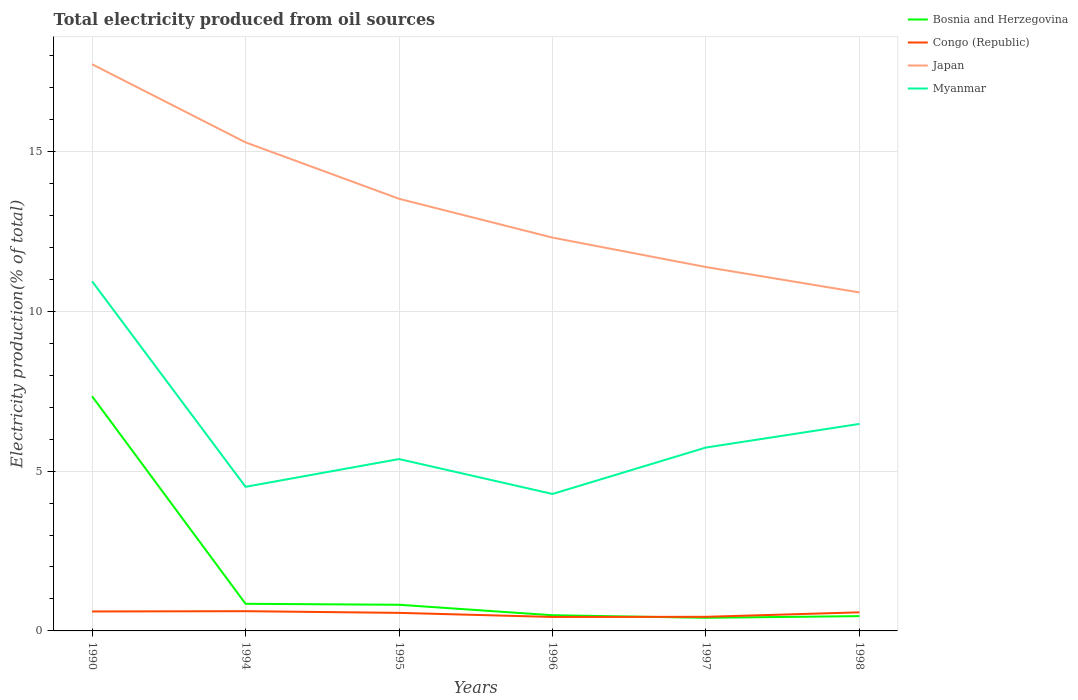Across all years, what is the maximum total electricity produced in Congo (Republic)?
Your answer should be very brief. 0.44. What is the total total electricity produced in Myanmar in the graph?
Give a very brief answer. -1.97. What is the difference between the highest and the second highest total electricity produced in Myanmar?
Provide a succinct answer. 6.65. What is the difference between the highest and the lowest total electricity produced in Congo (Republic)?
Your answer should be very brief. 4. How many lines are there?
Offer a terse response. 4. How many years are there in the graph?
Offer a very short reply. 6. Does the graph contain any zero values?
Your answer should be compact. No. Does the graph contain grids?
Your answer should be compact. Yes. Where does the legend appear in the graph?
Your response must be concise. Top right. How many legend labels are there?
Your answer should be very brief. 4. How are the legend labels stacked?
Make the answer very short. Vertical. What is the title of the graph?
Your answer should be very brief. Total electricity produced from oil sources. What is the label or title of the X-axis?
Your answer should be compact. Years. What is the Electricity production(% of total) of Bosnia and Herzegovina in 1990?
Provide a short and direct response. 7.34. What is the Electricity production(% of total) in Congo (Republic) in 1990?
Your response must be concise. 0.61. What is the Electricity production(% of total) of Japan in 1990?
Provide a succinct answer. 17.72. What is the Electricity production(% of total) of Myanmar in 1990?
Give a very brief answer. 10.94. What is the Electricity production(% of total) of Bosnia and Herzegovina in 1994?
Make the answer very short. 0.85. What is the Electricity production(% of total) in Congo (Republic) in 1994?
Ensure brevity in your answer.  0.62. What is the Electricity production(% of total) in Japan in 1994?
Your answer should be compact. 15.28. What is the Electricity production(% of total) of Myanmar in 1994?
Offer a terse response. 4.51. What is the Electricity production(% of total) of Bosnia and Herzegovina in 1995?
Offer a very short reply. 0.82. What is the Electricity production(% of total) of Congo (Republic) in 1995?
Make the answer very short. 0.56. What is the Electricity production(% of total) in Japan in 1995?
Your answer should be compact. 13.52. What is the Electricity production(% of total) of Myanmar in 1995?
Make the answer very short. 5.38. What is the Electricity production(% of total) of Bosnia and Herzegovina in 1996?
Your response must be concise. 0.49. What is the Electricity production(% of total) of Congo (Republic) in 1996?
Your answer should be very brief. 0.44. What is the Electricity production(% of total) in Japan in 1996?
Your answer should be compact. 12.3. What is the Electricity production(% of total) in Myanmar in 1996?
Your answer should be compact. 4.28. What is the Electricity production(% of total) in Bosnia and Herzegovina in 1997?
Provide a short and direct response. 0.41. What is the Electricity production(% of total) in Congo (Republic) in 1997?
Make the answer very short. 0.44. What is the Electricity production(% of total) in Japan in 1997?
Offer a terse response. 11.38. What is the Electricity production(% of total) of Myanmar in 1997?
Provide a succinct answer. 5.74. What is the Electricity production(% of total) in Bosnia and Herzegovina in 1998?
Provide a short and direct response. 0.46. What is the Electricity production(% of total) in Congo (Republic) in 1998?
Provide a short and direct response. 0.58. What is the Electricity production(% of total) in Japan in 1998?
Your response must be concise. 10.59. What is the Electricity production(% of total) of Myanmar in 1998?
Offer a very short reply. 6.47. Across all years, what is the maximum Electricity production(% of total) in Bosnia and Herzegovina?
Provide a succinct answer. 7.34. Across all years, what is the maximum Electricity production(% of total) of Congo (Republic)?
Your answer should be compact. 0.62. Across all years, what is the maximum Electricity production(% of total) of Japan?
Provide a succinct answer. 17.72. Across all years, what is the maximum Electricity production(% of total) of Myanmar?
Give a very brief answer. 10.94. Across all years, what is the minimum Electricity production(% of total) of Bosnia and Herzegovina?
Ensure brevity in your answer.  0.41. Across all years, what is the minimum Electricity production(% of total) in Congo (Republic)?
Offer a very short reply. 0.44. Across all years, what is the minimum Electricity production(% of total) of Japan?
Your answer should be very brief. 10.59. Across all years, what is the minimum Electricity production(% of total) in Myanmar?
Keep it short and to the point. 4.28. What is the total Electricity production(% of total) in Bosnia and Herzegovina in the graph?
Offer a very short reply. 10.37. What is the total Electricity production(% of total) of Congo (Republic) in the graph?
Make the answer very short. 3.25. What is the total Electricity production(% of total) in Japan in the graph?
Provide a succinct answer. 80.8. What is the total Electricity production(% of total) of Myanmar in the graph?
Your response must be concise. 37.32. What is the difference between the Electricity production(% of total) of Bosnia and Herzegovina in 1990 and that in 1994?
Your answer should be very brief. 6.49. What is the difference between the Electricity production(% of total) in Congo (Republic) in 1990 and that in 1994?
Ensure brevity in your answer.  -0.01. What is the difference between the Electricity production(% of total) of Japan in 1990 and that in 1994?
Provide a short and direct response. 2.44. What is the difference between the Electricity production(% of total) in Myanmar in 1990 and that in 1994?
Provide a short and direct response. 6.43. What is the difference between the Electricity production(% of total) in Bosnia and Herzegovina in 1990 and that in 1995?
Provide a short and direct response. 6.52. What is the difference between the Electricity production(% of total) in Congo (Republic) in 1990 and that in 1995?
Offer a terse response. 0.04. What is the difference between the Electricity production(% of total) of Japan in 1990 and that in 1995?
Provide a short and direct response. 4.21. What is the difference between the Electricity production(% of total) in Myanmar in 1990 and that in 1995?
Make the answer very short. 5.56. What is the difference between the Electricity production(% of total) of Bosnia and Herzegovina in 1990 and that in 1996?
Keep it short and to the point. 6.85. What is the difference between the Electricity production(% of total) of Congo (Republic) in 1990 and that in 1996?
Provide a succinct answer. 0.17. What is the difference between the Electricity production(% of total) in Japan in 1990 and that in 1996?
Your response must be concise. 5.42. What is the difference between the Electricity production(% of total) in Myanmar in 1990 and that in 1996?
Provide a short and direct response. 6.65. What is the difference between the Electricity production(% of total) in Bosnia and Herzegovina in 1990 and that in 1997?
Provide a succinct answer. 6.93. What is the difference between the Electricity production(% of total) in Congo (Republic) in 1990 and that in 1997?
Provide a short and direct response. 0.17. What is the difference between the Electricity production(% of total) in Japan in 1990 and that in 1997?
Your answer should be very brief. 6.34. What is the difference between the Electricity production(% of total) in Myanmar in 1990 and that in 1997?
Your answer should be very brief. 5.2. What is the difference between the Electricity production(% of total) in Bosnia and Herzegovina in 1990 and that in 1998?
Your response must be concise. 6.88. What is the difference between the Electricity production(% of total) of Congo (Republic) in 1990 and that in 1998?
Offer a very short reply. 0.03. What is the difference between the Electricity production(% of total) of Japan in 1990 and that in 1998?
Give a very brief answer. 7.14. What is the difference between the Electricity production(% of total) of Myanmar in 1990 and that in 1998?
Keep it short and to the point. 4.46. What is the difference between the Electricity production(% of total) in Bosnia and Herzegovina in 1994 and that in 1995?
Make the answer very short. 0.03. What is the difference between the Electricity production(% of total) in Congo (Republic) in 1994 and that in 1995?
Your answer should be compact. 0.05. What is the difference between the Electricity production(% of total) of Japan in 1994 and that in 1995?
Provide a short and direct response. 1.76. What is the difference between the Electricity production(% of total) of Myanmar in 1994 and that in 1995?
Provide a short and direct response. -0.87. What is the difference between the Electricity production(% of total) in Bosnia and Herzegovina in 1994 and that in 1996?
Make the answer very short. 0.36. What is the difference between the Electricity production(% of total) in Congo (Republic) in 1994 and that in 1996?
Offer a terse response. 0.18. What is the difference between the Electricity production(% of total) of Japan in 1994 and that in 1996?
Offer a very short reply. 2.98. What is the difference between the Electricity production(% of total) in Myanmar in 1994 and that in 1996?
Ensure brevity in your answer.  0.22. What is the difference between the Electricity production(% of total) of Bosnia and Herzegovina in 1994 and that in 1997?
Give a very brief answer. 0.44. What is the difference between the Electricity production(% of total) of Congo (Republic) in 1994 and that in 1997?
Your answer should be compact. 0.18. What is the difference between the Electricity production(% of total) in Japan in 1994 and that in 1997?
Ensure brevity in your answer.  3.9. What is the difference between the Electricity production(% of total) in Myanmar in 1994 and that in 1997?
Keep it short and to the point. -1.23. What is the difference between the Electricity production(% of total) in Bosnia and Herzegovina in 1994 and that in 1998?
Keep it short and to the point. 0.39. What is the difference between the Electricity production(% of total) of Congo (Republic) in 1994 and that in 1998?
Offer a terse response. 0.04. What is the difference between the Electricity production(% of total) in Japan in 1994 and that in 1998?
Make the answer very short. 4.69. What is the difference between the Electricity production(% of total) of Myanmar in 1994 and that in 1998?
Your response must be concise. -1.97. What is the difference between the Electricity production(% of total) of Bosnia and Herzegovina in 1995 and that in 1996?
Offer a very short reply. 0.33. What is the difference between the Electricity production(% of total) of Congo (Republic) in 1995 and that in 1996?
Give a very brief answer. 0.13. What is the difference between the Electricity production(% of total) in Japan in 1995 and that in 1996?
Make the answer very short. 1.21. What is the difference between the Electricity production(% of total) of Myanmar in 1995 and that in 1996?
Provide a succinct answer. 1.09. What is the difference between the Electricity production(% of total) in Bosnia and Herzegovina in 1995 and that in 1997?
Your answer should be very brief. 0.41. What is the difference between the Electricity production(% of total) of Congo (Republic) in 1995 and that in 1997?
Your answer should be compact. 0.12. What is the difference between the Electricity production(% of total) of Japan in 1995 and that in 1997?
Make the answer very short. 2.14. What is the difference between the Electricity production(% of total) of Myanmar in 1995 and that in 1997?
Ensure brevity in your answer.  -0.36. What is the difference between the Electricity production(% of total) in Bosnia and Herzegovina in 1995 and that in 1998?
Your answer should be compact. 0.36. What is the difference between the Electricity production(% of total) of Congo (Republic) in 1995 and that in 1998?
Keep it short and to the point. -0.02. What is the difference between the Electricity production(% of total) of Japan in 1995 and that in 1998?
Provide a short and direct response. 2.93. What is the difference between the Electricity production(% of total) in Myanmar in 1995 and that in 1998?
Your answer should be very brief. -1.1. What is the difference between the Electricity production(% of total) of Bosnia and Herzegovina in 1996 and that in 1997?
Provide a succinct answer. 0.08. What is the difference between the Electricity production(% of total) of Congo (Republic) in 1996 and that in 1997?
Keep it short and to the point. -0. What is the difference between the Electricity production(% of total) of Japan in 1996 and that in 1997?
Keep it short and to the point. 0.92. What is the difference between the Electricity production(% of total) of Myanmar in 1996 and that in 1997?
Offer a terse response. -1.45. What is the difference between the Electricity production(% of total) of Bosnia and Herzegovina in 1996 and that in 1998?
Your answer should be very brief. 0.03. What is the difference between the Electricity production(% of total) in Congo (Republic) in 1996 and that in 1998?
Your answer should be compact. -0.14. What is the difference between the Electricity production(% of total) in Japan in 1996 and that in 1998?
Ensure brevity in your answer.  1.72. What is the difference between the Electricity production(% of total) in Myanmar in 1996 and that in 1998?
Your answer should be very brief. -2.19. What is the difference between the Electricity production(% of total) in Bosnia and Herzegovina in 1997 and that in 1998?
Provide a short and direct response. -0.05. What is the difference between the Electricity production(% of total) in Congo (Republic) in 1997 and that in 1998?
Your answer should be compact. -0.14. What is the difference between the Electricity production(% of total) of Japan in 1997 and that in 1998?
Ensure brevity in your answer.  0.79. What is the difference between the Electricity production(% of total) of Myanmar in 1997 and that in 1998?
Offer a very short reply. -0.74. What is the difference between the Electricity production(% of total) of Bosnia and Herzegovina in 1990 and the Electricity production(% of total) of Congo (Republic) in 1994?
Offer a very short reply. 6.72. What is the difference between the Electricity production(% of total) of Bosnia and Herzegovina in 1990 and the Electricity production(% of total) of Japan in 1994?
Give a very brief answer. -7.94. What is the difference between the Electricity production(% of total) of Bosnia and Herzegovina in 1990 and the Electricity production(% of total) of Myanmar in 1994?
Provide a succinct answer. 2.83. What is the difference between the Electricity production(% of total) in Congo (Republic) in 1990 and the Electricity production(% of total) in Japan in 1994?
Your answer should be very brief. -14.67. What is the difference between the Electricity production(% of total) in Congo (Republic) in 1990 and the Electricity production(% of total) in Myanmar in 1994?
Offer a terse response. -3.9. What is the difference between the Electricity production(% of total) of Japan in 1990 and the Electricity production(% of total) of Myanmar in 1994?
Provide a succinct answer. 13.22. What is the difference between the Electricity production(% of total) in Bosnia and Herzegovina in 1990 and the Electricity production(% of total) in Congo (Republic) in 1995?
Make the answer very short. 6.78. What is the difference between the Electricity production(% of total) in Bosnia and Herzegovina in 1990 and the Electricity production(% of total) in Japan in 1995?
Offer a very short reply. -6.18. What is the difference between the Electricity production(% of total) of Bosnia and Herzegovina in 1990 and the Electricity production(% of total) of Myanmar in 1995?
Give a very brief answer. 1.96. What is the difference between the Electricity production(% of total) of Congo (Republic) in 1990 and the Electricity production(% of total) of Japan in 1995?
Your answer should be compact. -12.91. What is the difference between the Electricity production(% of total) of Congo (Republic) in 1990 and the Electricity production(% of total) of Myanmar in 1995?
Make the answer very short. -4.77. What is the difference between the Electricity production(% of total) of Japan in 1990 and the Electricity production(% of total) of Myanmar in 1995?
Your response must be concise. 12.35. What is the difference between the Electricity production(% of total) of Bosnia and Herzegovina in 1990 and the Electricity production(% of total) of Congo (Republic) in 1996?
Offer a terse response. 6.9. What is the difference between the Electricity production(% of total) of Bosnia and Herzegovina in 1990 and the Electricity production(% of total) of Japan in 1996?
Make the answer very short. -4.96. What is the difference between the Electricity production(% of total) of Bosnia and Herzegovina in 1990 and the Electricity production(% of total) of Myanmar in 1996?
Your response must be concise. 3.06. What is the difference between the Electricity production(% of total) in Congo (Republic) in 1990 and the Electricity production(% of total) in Japan in 1996?
Offer a very short reply. -11.69. What is the difference between the Electricity production(% of total) in Congo (Republic) in 1990 and the Electricity production(% of total) in Myanmar in 1996?
Your response must be concise. -3.68. What is the difference between the Electricity production(% of total) of Japan in 1990 and the Electricity production(% of total) of Myanmar in 1996?
Provide a succinct answer. 13.44. What is the difference between the Electricity production(% of total) of Bosnia and Herzegovina in 1990 and the Electricity production(% of total) of Congo (Republic) in 1997?
Provide a succinct answer. 6.9. What is the difference between the Electricity production(% of total) in Bosnia and Herzegovina in 1990 and the Electricity production(% of total) in Japan in 1997?
Provide a succinct answer. -4.04. What is the difference between the Electricity production(% of total) in Bosnia and Herzegovina in 1990 and the Electricity production(% of total) in Myanmar in 1997?
Your answer should be compact. 1.6. What is the difference between the Electricity production(% of total) in Congo (Republic) in 1990 and the Electricity production(% of total) in Japan in 1997?
Your response must be concise. -10.77. What is the difference between the Electricity production(% of total) in Congo (Republic) in 1990 and the Electricity production(% of total) in Myanmar in 1997?
Provide a succinct answer. -5.13. What is the difference between the Electricity production(% of total) of Japan in 1990 and the Electricity production(% of total) of Myanmar in 1997?
Your answer should be very brief. 11.99. What is the difference between the Electricity production(% of total) of Bosnia and Herzegovina in 1990 and the Electricity production(% of total) of Congo (Republic) in 1998?
Make the answer very short. 6.76. What is the difference between the Electricity production(% of total) in Bosnia and Herzegovina in 1990 and the Electricity production(% of total) in Japan in 1998?
Offer a very short reply. -3.25. What is the difference between the Electricity production(% of total) of Bosnia and Herzegovina in 1990 and the Electricity production(% of total) of Myanmar in 1998?
Ensure brevity in your answer.  0.87. What is the difference between the Electricity production(% of total) in Congo (Republic) in 1990 and the Electricity production(% of total) in Japan in 1998?
Your answer should be compact. -9.98. What is the difference between the Electricity production(% of total) in Congo (Republic) in 1990 and the Electricity production(% of total) in Myanmar in 1998?
Your answer should be compact. -5.87. What is the difference between the Electricity production(% of total) of Japan in 1990 and the Electricity production(% of total) of Myanmar in 1998?
Provide a succinct answer. 11.25. What is the difference between the Electricity production(% of total) of Bosnia and Herzegovina in 1994 and the Electricity production(% of total) of Congo (Republic) in 1995?
Your answer should be compact. 0.28. What is the difference between the Electricity production(% of total) in Bosnia and Herzegovina in 1994 and the Electricity production(% of total) in Japan in 1995?
Offer a terse response. -12.67. What is the difference between the Electricity production(% of total) of Bosnia and Herzegovina in 1994 and the Electricity production(% of total) of Myanmar in 1995?
Offer a very short reply. -4.53. What is the difference between the Electricity production(% of total) in Congo (Republic) in 1994 and the Electricity production(% of total) in Japan in 1995?
Your answer should be compact. -12.9. What is the difference between the Electricity production(% of total) in Congo (Republic) in 1994 and the Electricity production(% of total) in Myanmar in 1995?
Offer a very short reply. -4.76. What is the difference between the Electricity production(% of total) in Japan in 1994 and the Electricity production(% of total) in Myanmar in 1995?
Offer a very short reply. 9.91. What is the difference between the Electricity production(% of total) of Bosnia and Herzegovina in 1994 and the Electricity production(% of total) of Congo (Republic) in 1996?
Offer a very short reply. 0.41. What is the difference between the Electricity production(% of total) of Bosnia and Herzegovina in 1994 and the Electricity production(% of total) of Japan in 1996?
Keep it short and to the point. -11.45. What is the difference between the Electricity production(% of total) in Bosnia and Herzegovina in 1994 and the Electricity production(% of total) in Myanmar in 1996?
Your response must be concise. -3.44. What is the difference between the Electricity production(% of total) of Congo (Republic) in 1994 and the Electricity production(% of total) of Japan in 1996?
Your answer should be very brief. -11.69. What is the difference between the Electricity production(% of total) in Congo (Republic) in 1994 and the Electricity production(% of total) in Myanmar in 1996?
Your answer should be compact. -3.67. What is the difference between the Electricity production(% of total) of Japan in 1994 and the Electricity production(% of total) of Myanmar in 1996?
Make the answer very short. 11. What is the difference between the Electricity production(% of total) in Bosnia and Herzegovina in 1994 and the Electricity production(% of total) in Congo (Republic) in 1997?
Give a very brief answer. 0.41. What is the difference between the Electricity production(% of total) in Bosnia and Herzegovina in 1994 and the Electricity production(% of total) in Japan in 1997?
Ensure brevity in your answer.  -10.53. What is the difference between the Electricity production(% of total) of Bosnia and Herzegovina in 1994 and the Electricity production(% of total) of Myanmar in 1997?
Make the answer very short. -4.89. What is the difference between the Electricity production(% of total) in Congo (Republic) in 1994 and the Electricity production(% of total) in Japan in 1997?
Make the answer very short. -10.76. What is the difference between the Electricity production(% of total) of Congo (Republic) in 1994 and the Electricity production(% of total) of Myanmar in 1997?
Provide a short and direct response. -5.12. What is the difference between the Electricity production(% of total) in Japan in 1994 and the Electricity production(% of total) in Myanmar in 1997?
Your answer should be compact. 9.54. What is the difference between the Electricity production(% of total) of Bosnia and Herzegovina in 1994 and the Electricity production(% of total) of Congo (Republic) in 1998?
Keep it short and to the point. 0.27. What is the difference between the Electricity production(% of total) of Bosnia and Herzegovina in 1994 and the Electricity production(% of total) of Japan in 1998?
Make the answer very short. -9.74. What is the difference between the Electricity production(% of total) in Bosnia and Herzegovina in 1994 and the Electricity production(% of total) in Myanmar in 1998?
Keep it short and to the point. -5.63. What is the difference between the Electricity production(% of total) in Congo (Republic) in 1994 and the Electricity production(% of total) in Japan in 1998?
Offer a terse response. -9.97. What is the difference between the Electricity production(% of total) of Congo (Republic) in 1994 and the Electricity production(% of total) of Myanmar in 1998?
Offer a terse response. -5.86. What is the difference between the Electricity production(% of total) in Japan in 1994 and the Electricity production(% of total) in Myanmar in 1998?
Ensure brevity in your answer.  8.81. What is the difference between the Electricity production(% of total) in Bosnia and Herzegovina in 1995 and the Electricity production(% of total) in Congo (Republic) in 1996?
Give a very brief answer. 0.38. What is the difference between the Electricity production(% of total) in Bosnia and Herzegovina in 1995 and the Electricity production(% of total) in Japan in 1996?
Provide a succinct answer. -11.48. What is the difference between the Electricity production(% of total) of Bosnia and Herzegovina in 1995 and the Electricity production(% of total) of Myanmar in 1996?
Offer a very short reply. -3.47. What is the difference between the Electricity production(% of total) in Congo (Republic) in 1995 and the Electricity production(% of total) in Japan in 1996?
Your response must be concise. -11.74. What is the difference between the Electricity production(% of total) in Congo (Republic) in 1995 and the Electricity production(% of total) in Myanmar in 1996?
Make the answer very short. -3.72. What is the difference between the Electricity production(% of total) of Japan in 1995 and the Electricity production(% of total) of Myanmar in 1996?
Your answer should be very brief. 9.23. What is the difference between the Electricity production(% of total) in Bosnia and Herzegovina in 1995 and the Electricity production(% of total) in Congo (Republic) in 1997?
Your answer should be compact. 0.38. What is the difference between the Electricity production(% of total) in Bosnia and Herzegovina in 1995 and the Electricity production(% of total) in Japan in 1997?
Your answer should be very brief. -10.56. What is the difference between the Electricity production(% of total) in Bosnia and Herzegovina in 1995 and the Electricity production(% of total) in Myanmar in 1997?
Ensure brevity in your answer.  -4.92. What is the difference between the Electricity production(% of total) of Congo (Republic) in 1995 and the Electricity production(% of total) of Japan in 1997?
Give a very brief answer. -10.82. What is the difference between the Electricity production(% of total) in Congo (Republic) in 1995 and the Electricity production(% of total) in Myanmar in 1997?
Ensure brevity in your answer.  -5.17. What is the difference between the Electricity production(% of total) in Japan in 1995 and the Electricity production(% of total) in Myanmar in 1997?
Provide a succinct answer. 7.78. What is the difference between the Electricity production(% of total) in Bosnia and Herzegovina in 1995 and the Electricity production(% of total) in Congo (Republic) in 1998?
Ensure brevity in your answer.  0.24. What is the difference between the Electricity production(% of total) of Bosnia and Herzegovina in 1995 and the Electricity production(% of total) of Japan in 1998?
Your response must be concise. -9.77. What is the difference between the Electricity production(% of total) of Bosnia and Herzegovina in 1995 and the Electricity production(% of total) of Myanmar in 1998?
Provide a succinct answer. -5.66. What is the difference between the Electricity production(% of total) of Congo (Republic) in 1995 and the Electricity production(% of total) of Japan in 1998?
Provide a short and direct response. -10.02. What is the difference between the Electricity production(% of total) in Congo (Republic) in 1995 and the Electricity production(% of total) in Myanmar in 1998?
Your answer should be compact. -5.91. What is the difference between the Electricity production(% of total) in Japan in 1995 and the Electricity production(% of total) in Myanmar in 1998?
Give a very brief answer. 7.04. What is the difference between the Electricity production(% of total) in Bosnia and Herzegovina in 1996 and the Electricity production(% of total) in Congo (Republic) in 1997?
Give a very brief answer. 0.05. What is the difference between the Electricity production(% of total) of Bosnia and Herzegovina in 1996 and the Electricity production(% of total) of Japan in 1997?
Your answer should be very brief. -10.89. What is the difference between the Electricity production(% of total) of Bosnia and Herzegovina in 1996 and the Electricity production(% of total) of Myanmar in 1997?
Keep it short and to the point. -5.25. What is the difference between the Electricity production(% of total) in Congo (Republic) in 1996 and the Electricity production(% of total) in Japan in 1997?
Make the answer very short. -10.95. What is the difference between the Electricity production(% of total) in Congo (Republic) in 1996 and the Electricity production(% of total) in Myanmar in 1997?
Provide a short and direct response. -5.3. What is the difference between the Electricity production(% of total) in Japan in 1996 and the Electricity production(% of total) in Myanmar in 1997?
Keep it short and to the point. 6.57. What is the difference between the Electricity production(% of total) in Bosnia and Herzegovina in 1996 and the Electricity production(% of total) in Congo (Republic) in 1998?
Provide a succinct answer. -0.09. What is the difference between the Electricity production(% of total) of Bosnia and Herzegovina in 1996 and the Electricity production(% of total) of Japan in 1998?
Make the answer very short. -10.1. What is the difference between the Electricity production(% of total) of Bosnia and Herzegovina in 1996 and the Electricity production(% of total) of Myanmar in 1998?
Provide a succinct answer. -5.98. What is the difference between the Electricity production(% of total) in Congo (Republic) in 1996 and the Electricity production(% of total) in Japan in 1998?
Keep it short and to the point. -10.15. What is the difference between the Electricity production(% of total) of Congo (Republic) in 1996 and the Electricity production(% of total) of Myanmar in 1998?
Keep it short and to the point. -6.04. What is the difference between the Electricity production(% of total) in Japan in 1996 and the Electricity production(% of total) in Myanmar in 1998?
Make the answer very short. 5.83. What is the difference between the Electricity production(% of total) in Bosnia and Herzegovina in 1997 and the Electricity production(% of total) in Congo (Republic) in 1998?
Keep it short and to the point. -0.17. What is the difference between the Electricity production(% of total) of Bosnia and Herzegovina in 1997 and the Electricity production(% of total) of Japan in 1998?
Offer a terse response. -10.18. What is the difference between the Electricity production(% of total) in Bosnia and Herzegovina in 1997 and the Electricity production(% of total) in Myanmar in 1998?
Offer a terse response. -6.06. What is the difference between the Electricity production(% of total) in Congo (Republic) in 1997 and the Electricity production(% of total) in Japan in 1998?
Provide a succinct answer. -10.15. What is the difference between the Electricity production(% of total) of Congo (Republic) in 1997 and the Electricity production(% of total) of Myanmar in 1998?
Keep it short and to the point. -6.03. What is the difference between the Electricity production(% of total) of Japan in 1997 and the Electricity production(% of total) of Myanmar in 1998?
Offer a terse response. 4.91. What is the average Electricity production(% of total) in Bosnia and Herzegovina per year?
Provide a succinct answer. 1.73. What is the average Electricity production(% of total) in Congo (Republic) per year?
Make the answer very short. 0.54. What is the average Electricity production(% of total) of Japan per year?
Your response must be concise. 13.47. What is the average Electricity production(% of total) of Myanmar per year?
Your response must be concise. 6.22. In the year 1990, what is the difference between the Electricity production(% of total) of Bosnia and Herzegovina and Electricity production(% of total) of Congo (Republic)?
Give a very brief answer. 6.73. In the year 1990, what is the difference between the Electricity production(% of total) of Bosnia and Herzegovina and Electricity production(% of total) of Japan?
Make the answer very short. -10.38. In the year 1990, what is the difference between the Electricity production(% of total) of Bosnia and Herzegovina and Electricity production(% of total) of Myanmar?
Your answer should be compact. -3.6. In the year 1990, what is the difference between the Electricity production(% of total) in Congo (Republic) and Electricity production(% of total) in Japan?
Keep it short and to the point. -17.12. In the year 1990, what is the difference between the Electricity production(% of total) of Congo (Republic) and Electricity production(% of total) of Myanmar?
Offer a very short reply. -10.33. In the year 1990, what is the difference between the Electricity production(% of total) in Japan and Electricity production(% of total) in Myanmar?
Your answer should be compact. 6.79. In the year 1994, what is the difference between the Electricity production(% of total) in Bosnia and Herzegovina and Electricity production(% of total) in Congo (Republic)?
Provide a succinct answer. 0.23. In the year 1994, what is the difference between the Electricity production(% of total) in Bosnia and Herzegovina and Electricity production(% of total) in Japan?
Offer a very short reply. -14.43. In the year 1994, what is the difference between the Electricity production(% of total) in Bosnia and Herzegovina and Electricity production(% of total) in Myanmar?
Give a very brief answer. -3.66. In the year 1994, what is the difference between the Electricity production(% of total) of Congo (Republic) and Electricity production(% of total) of Japan?
Ensure brevity in your answer.  -14.66. In the year 1994, what is the difference between the Electricity production(% of total) in Congo (Republic) and Electricity production(% of total) in Myanmar?
Keep it short and to the point. -3.89. In the year 1994, what is the difference between the Electricity production(% of total) of Japan and Electricity production(% of total) of Myanmar?
Your response must be concise. 10.77. In the year 1995, what is the difference between the Electricity production(% of total) of Bosnia and Herzegovina and Electricity production(% of total) of Congo (Republic)?
Ensure brevity in your answer.  0.25. In the year 1995, what is the difference between the Electricity production(% of total) of Bosnia and Herzegovina and Electricity production(% of total) of Japan?
Provide a short and direct response. -12.7. In the year 1995, what is the difference between the Electricity production(% of total) of Bosnia and Herzegovina and Electricity production(% of total) of Myanmar?
Your response must be concise. -4.56. In the year 1995, what is the difference between the Electricity production(% of total) of Congo (Republic) and Electricity production(% of total) of Japan?
Give a very brief answer. -12.95. In the year 1995, what is the difference between the Electricity production(% of total) in Congo (Republic) and Electricity production(% of total) in Myanmar?
Keep it short and to the point. -4.81. In the year 1995, what is the difference between the Electricity production(% of total) in Japan and Electricity production(% of total) in Myanmar?
Your answer should be very brief. 8.14. In the year 1996, what is the difference between the Electricity production(% of total) in Bosnia and Herzegovina and Electricity production(% of total) in Congo (Republic)?
Keep it short and to the point. 0.05. In the year 1996, what is the difference between the Electricity production(% of total) of Bosnia and Herzegovina and Electricity production(% of total) of Japan?
Provide a succinct answer. -11.81. In the year 1996, what is the difference between the Electricity production(% of total) of Bosnia and Herzegovina and Electricity production(% of total) of Myanmar?
Make the answer very short. -3.79. In the year 1996, what is the difference between the Electricity production(% of total) in Congo (Republic) and Electricity production(% of total) in Japan?
Keep it short and to the point. -11.87. In the year 1996, what is the difference between the Electricity production(% of total) in Congo (Republic) and Electricity production(% of total) in Myanmar?
Make the answer very short. -3.85. In the year 1996, what is the difference between the Electricity production(% of total) in Japan and Electricity production(% of total) in Myanmar?
Give a very brief answer. 8.02. In the year 1997, what is the difference between the Electricity production(% of total) in Bosnia and Herzegovina and Electricity production(% of total) in Congo (Republic)?
Ensure brevity in your answer.  -0.03. In the year 1997, what is the difference between the Electricity production(% of total) in Bosnia and Herzegovina and Electricity production(% of total) in Japan?
Ensure brevity in your answer.  -10.97. In the year 1997, what is the difference between the Electricity production(% of total) in Bosnia and Herzegovina and Electricity production(% of total) in Myanmar?
Offer a terse response. -5.33. In the year 1997, what is the difference between the Electricity production(% of total) in Congo (Republic) and Electricity production(% of total) in Japan?
Offer a very short reply. -10.94. In the year 1997, what is the difference between the Electricity production(% of total) of Congo (Republic) and Electricity production(% of total) of Myanmar?
Your response must be concise. -5.3. In the year 1997, what is the difference between the Electricity production(% of total) in Japan and Electricity production(% of total) in Myanmar?
Provide a short and direct response. 5.65. In the year 1998, what is the difference between the Electricity production(% of total) of Bosnia and Herzegovina and Electricity production(% of total) of Congo (Republic)?
Keep it short and to the point. -0.12. In the year 1998, what is the difference between the Electricity production(% of total) of Bosnia and Herzegovina and Electricity production(% of total) of Japan?
Your answer should be very brief. -10.12. In the year 1998, what is the difference between the Electricity production(% of total) of Bosnia and Herzegovina and Electricity production(% of total) of Myanmar?
Give a very brief answer. -6.01. In the year 1998, what is the difference between the Electricity production(% of total) of Congo (Republic) and Electricity production(% of total) of Japan?
Your response must be concise. -10.01. In the year 1998, what is the difference between the Electricity production(% of total) in Congo (Republic) and Electricity production(% of total) in Myanmar?
Make the answer very short. -5.89. In the year 1998, what is the difference between the Electricity production(% of total) in Japan and Electricity production(% of total) in Myanmar?
Offer a terse response. 4.11. What is the ratio of the Electricity production(% of total) in Bosnia and Herzegovina in 1990 to that in 1994?
Your answer should be compact. 8.65. What is the ratio of the Electricity production(% of total) in Congo (Republic) in 1990 to that in 1994?
Your answer should be compact. 0.99. What is the ratio of the Electricity production(% of total) of Japan in 1990 to that in 1994?
Your answer should be very brief. 1.16. What is the ratio of the Electricity production(% of total) of Myanmar in 1990 to that in 1994?
Ensure brevity in your answer.  2.43. What is the ratio of the Electricity production(% of total) in Bosnia and Herzegovina in 1990 to that in 1995?
Make the answer very short. 8.97. What is the ratio of the Electricity production(% of total) in Congo (Republic) in 1990 to that in 1995?
Make the answer very short. 1.08. What is the ratio of the Electricity production(% of total) of Japan in 1990 to that in 1995?
Make the answer very short. 1.31. What is the ratio of the Electricity production(% of total) in Myanmar in 1990 to that in 1995?
Give a very brief answer. 2.03. What is the ratio of the Electricity production(% of total) in Bosnia and Herzegovina in 1990 to that in 1996?
Your response must be concise. 14.97. What is the ratio of the Electricity production(% of total) of Congo (Republic) in 1990 to that in 1996?
Your answer should be compact. 1.39. What is the ratio of the Electricity production(% of total) in Japan in 1990 to that in 1996?
Ensure brevity in your answer.  1.44. What is the ratio of the Electricity production(% of total) of Myanmar in 1990 to that in 1996?
Keep it short and to the point. 2.55. What is the ratio of the Electricity production(% of total) in Bosnia and Herzegovina in 1990 to that in 1997?
Give a very brief answer. 17.87. What is the ratio of the Electricity production(% of total) in Congo (Republic) in 1990 to that in 1997?
Your answer should be very brief. 1.38. What is the ratio of the Electricity production(% of total) in Japan in 1990 to that in 1997?
Your response must be concise. 1.56. What is the ratio of the Electricity production(% of total) of Myanmar in 1990 to that in 1997?
Offer a terse response. 1.91. What is the ratio of the Electricity production(% of total) of Bosnia and Herzegovina in 1990 to that in 1998?
Provide a short and direct response. 15.86. What is the ratio of the Electricity production(% of total) of Congo (Republic) in 1990 to that in 1998?
Offer a very short reply. 1.05. What is the ratio of the Electricity production(% of total) in Japan in 1990 to that in 1998?
Offer a terse response. 1.67. What is the ratio of the Electricity production(% of total) in Myanmar in 1990 to that in 1998?
Provide a short and direct response. 1.69. What is the ratio of the Electricity production(% of total) in Congo (Republic) in 1994 to that in 1995?
Make the answer very short. 1.09. What is the ratio of the Electricity production(% of total) of Japan in 1994 to that in 1995?
Your answer should be compact. 1.13. What is the ratio of the Electricity production(% of total) in Myanmar in 1994 to that in 1995?
Your answer should be compact. 0.84. What is the ratio of the Electricity production(% of total) of Bosnia and Herzegovina in 1994 to that in 1996?
Your answer should be compact. 1.73. What is the ratio of the Electricity production(% of total) of Congo (Republic) in 1994 to that in 1996?
Offer a very short reply. 1.41. What is the ratio of the Electricity production(% of total) of Japan in 1994 to that in 1996?
Make the answer very short. 1.24. What is the ratio of the Electricity production(% of total) of Myanmar in 1994 to that in 1996?
Ensure brevity in your answer.  1.05. What is the ratio of the Electricity production(% of total) in Bosnia and Herzegovina in 1994 to that in 1997?
Provide a succinct answer. 2.07. What is the ratio of the Electricity production(% of total) in Congo (Republic) in 1994 to that in 1997?
Provide a succinct answer. 1.4. What is the ratio of the Electricity production(% of total) in Japan in 1994 to that in 1997?
Ensure brevity in your answer.  1.34. What is the ratio of the Electricity production(% of total) in Myanmar in 1994 to that in 1997?
Ensure brevity in your answer.  0.79. What is the ratio of the Electricity production(% of total) of Bosnia and Herzegovina in 1994 to that in 1998?
Keep it short and to the point. 1.83. What is the ratio of the Electricity production(% of total) in Congo (Republic) in 1994 to that in 1998?
Provide a succinct answer. 1.06. What is the ratio of the Electricity production(% of total) of Japan in 1994 to that in 1998?
Ensure brevity in your answer.  1.44. What is the ratio of the Electricity production(% of total) in Myanmar in 1994 to that in 1998?
Offer a very short reply. 0.7. What is the ratio of the Electricity production(% of total) of Bosnia and Herzegovina in 1995 to that in 1996?
Offer a terse response. 1.67. What is the ratio of the Electricity production(% of total) of Congo (Republic) in 1995 to that in 1996?
Provide a succinct answer. 1.29. What is the ratio of the Electricity production(% of total) of Japan in 1995 to that in 1996?
Provide a succinct answer. 1.1. What is the ratio of the Electricity production(% of total) of Myanmar in 1995 to that in 1996?
Your answer should be compact. 1.25. What is the ratio of the Electricity production(% of total) of Bosnia and Herzegovina in 1995 to that in 1997?
Offer a terse response. 1.99. What is the ratio of the Electricity production(% of total) of Congo (Republic) in 1995 to that in 1997?
Offer a terse response. 1.28. What is the ratio of the Electricity production(% of total) in Japan in 1995 to that in 1997?
Give a very brief answer. 1.19. What is the ratio of the Electricity production(% of total) of Myanmar in 1995 to that in 1997?
Offer a very short reply. 0.94. What is the ratio of the Electricity production(% of total) of Bosnia and Herzegovina in 1995 to that in 1998?
Your answer should be compact. 1.77. What is the ratio of the Electricity production(% of total) in Congo (Republic) in 1995 to that in 1998?
Give a very brief answer. 0.97. What is the ratio of the Electricity production(% of total) in Japan in 1995 to that in 1998?
Offer a terse response. 1.28. What is the ratio of the Electricity production(% of total) of Myanmar in 1995 to that in 1998?
Give a very brief answer. 0.83. What is the ratio of the Electricity production(% of total) of Bosnia and Herzegovina in 1996 to that in 1997?
Keep it short and to the point. 1.19. What is the ratio of the Electricity production(% of total) in Japan in 1996 to that in 1997?
Provide a succinct answer. 1.08. What is the ratio of the Electricity production(% of total) in Myanmar in 1996 to that in 1997?
Provide a succinct answer. 0.75. What is the ratio of the Electricity production(% of total) in Bosnia and Herzegovina in 1996 to that in 1998?
Offer a very short reply. 1.06. What is the ratio of the Electricity production(% of total) of Congo (Republic) in 1996 to that in 1998?
Your answer should be compact. 0.75. What is the ratio of the Electricity production(% of total) in Japan in 1996 to that in 1998?
Your answer should be compact. 1.16. What is the ratio of the Electricity production(% of total) of Myanmar in 1996 to that in 1998?
Your answer should be compact. 0.66. What is the ratio of the Electricity production(% of total) of Bosnia and Herzegovina in 1997 to that in 1998?
Your answer should be very brief. 0.89. What is the ratio of the Electricity production(% of total) in Congo (Republic) in 1997 to that in 1998?
Make the answer very short. 0.76. What is the ratio of the Electricity production(% of total) of Japan in 1997 to that in 1998?
Give a very brief answer. 1.08. What is the ratio of the Electricity production(% of total) of Myanmar in 1997 to that in 1998?
Your response must be concise. 0.89. What is the difference between the highest and the second highest Electricity production(% of total) of Bosnia and Herzegovina?
Your answer should be very brief. 6.49. What is the difference between the highest and the second highest Electricity production(% of total) of Congo (Republic)?
Keep it short and to the point. 0.01. What is the difference between the highest and the second highest Electricity production(% of total) in Japan?
Provide a short and direct response. 2.44. What is the difference between the highest and the second highest Electricity production(% of total) of Myanmar?
Your answer should be very brief. 4.46. What is the difference between the highest and the lowest Electricity production(% of total) in Bosnia and Herzegovina?
Your answer should be very brief. 6.93. What is the difference between the highest and the lowest Electricity production(% of total) in Congo (Republic)?
Ensure brevity in your answer.  0.18. What is the difference between the highest and the lowest Electricity production(% of total) in Japan?
Your answer should be compact. 7.14. What is the difference between the highest and the lowest Electricity production(% of total) in Myanmar?
Offer a terse response. 6.65. 